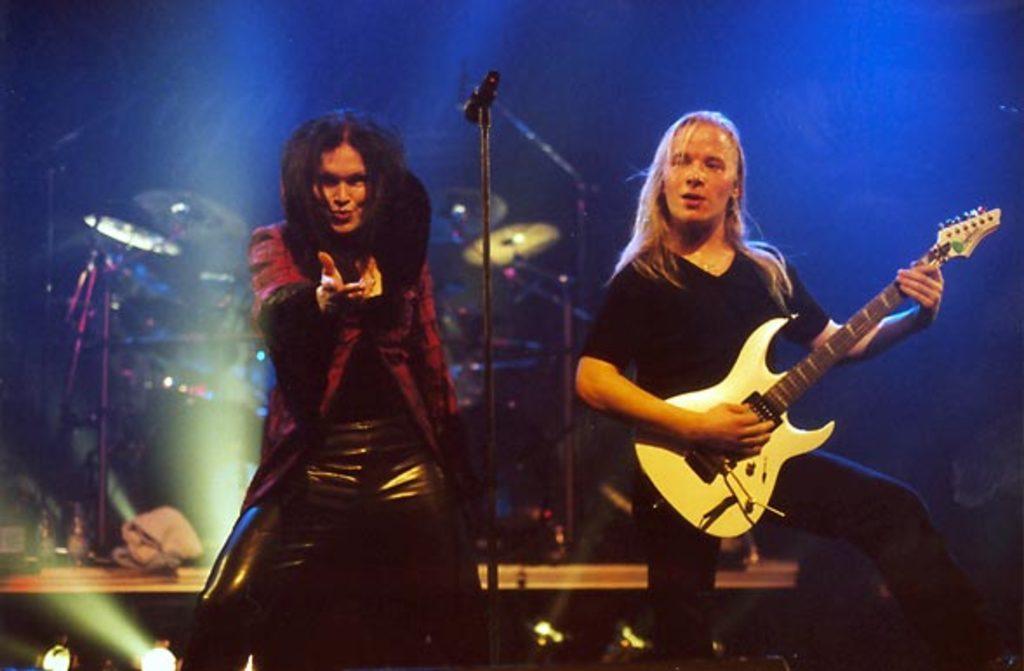In one or two sentences, can you explain what this image depicts? In this image we can see two persons are standing, there a man is holding the guitar in the hands, beside there is a microphone, at the back there are musical drums, there are lights, the background is in blue color. 